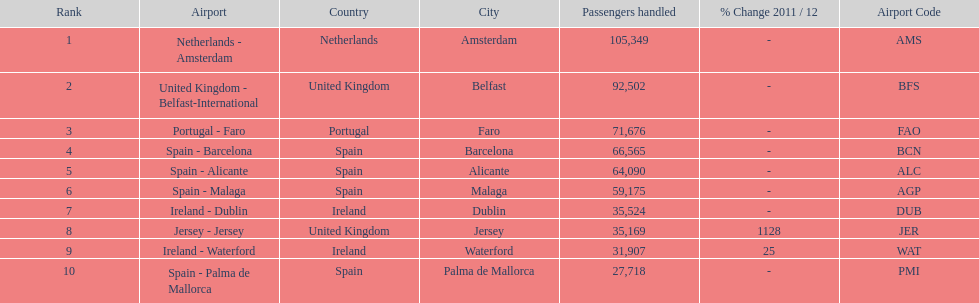How many airports are listed? 10. 